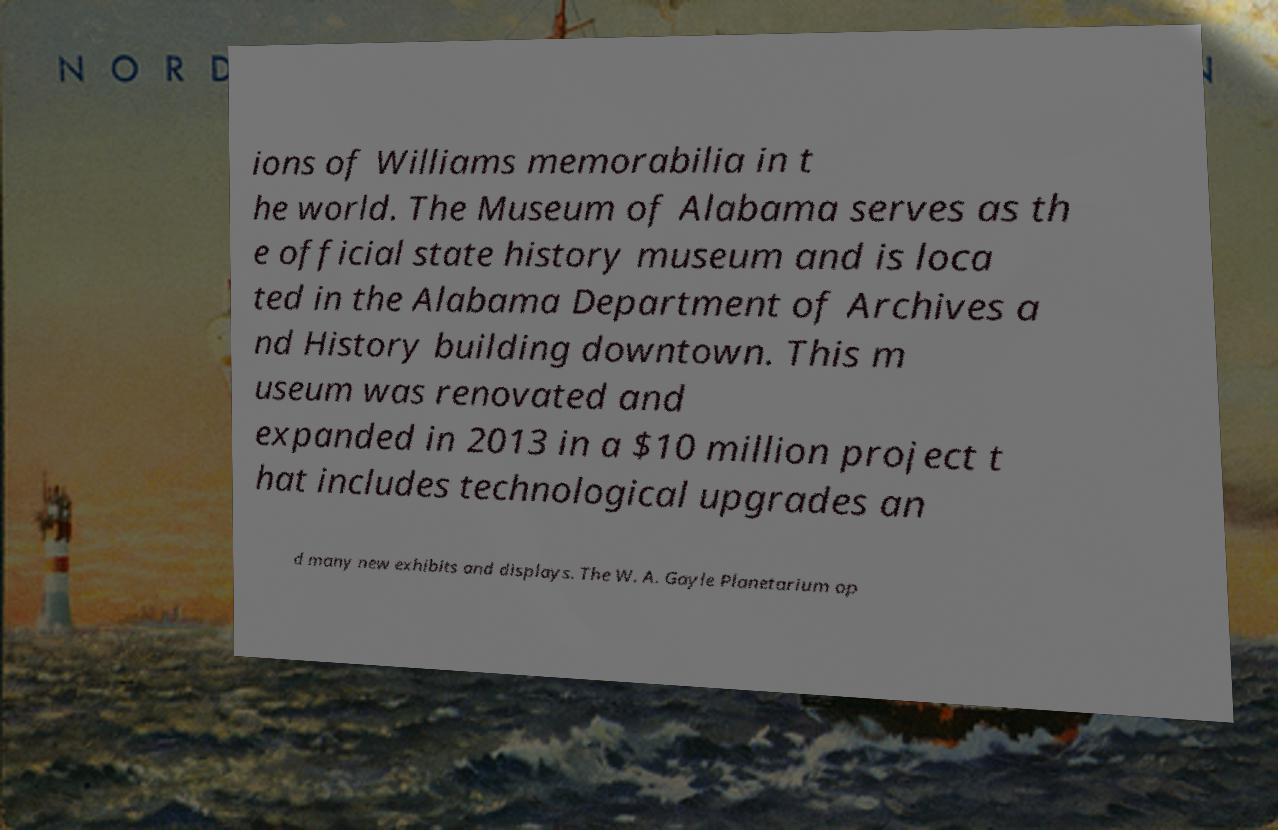Please identify and transcribe the text found in this image. ions of Williams memorabilia in t he world. The Museum of Alabama serves as th e official state history museum and is loca ted in the Alabama Department of Archives a nd History building downtown. This m useum was renovated and expanded in 2013 in a $10 million project t hat includes technological upgrades an d many new exhibits and displays. The W. A. Gayle Planetarium op 